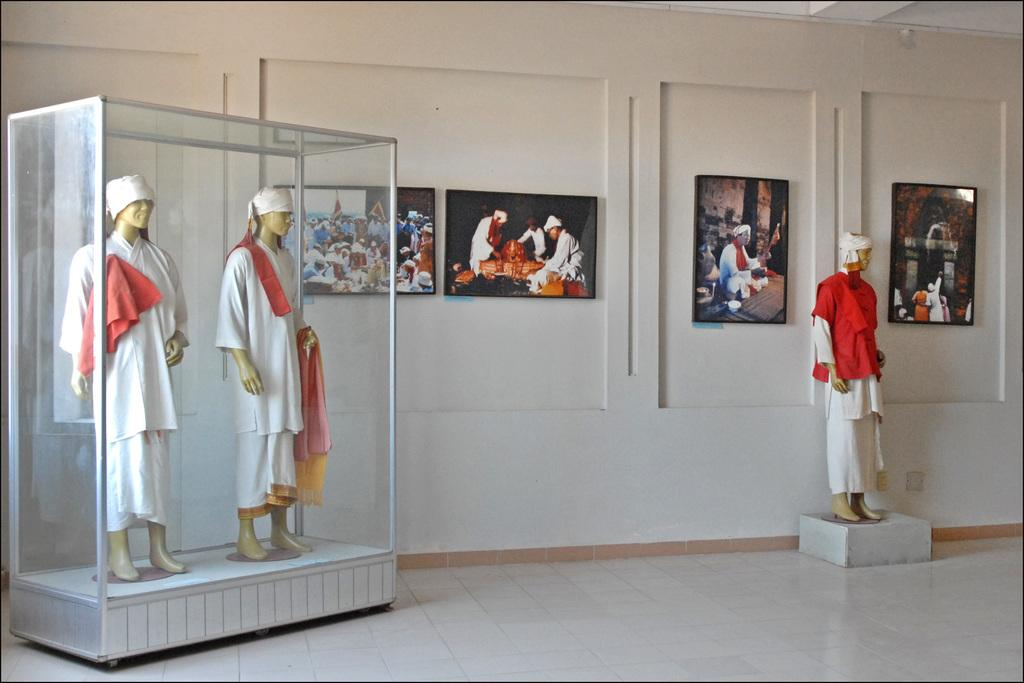What can be seen on the wall in the image? There are photo frames on the wall in the image. What is the transparent structure in the image? There is a glass box in the image. What is inside the glass box? There are mannequins inside the glass box. Are there any mannequins outside the glass box? Yes, there is a mannequin outside the glass box. How many passengers are on the train in the image? There is no train present in the image. What type of father is depicted in the image? There is no father depicted in the image. 